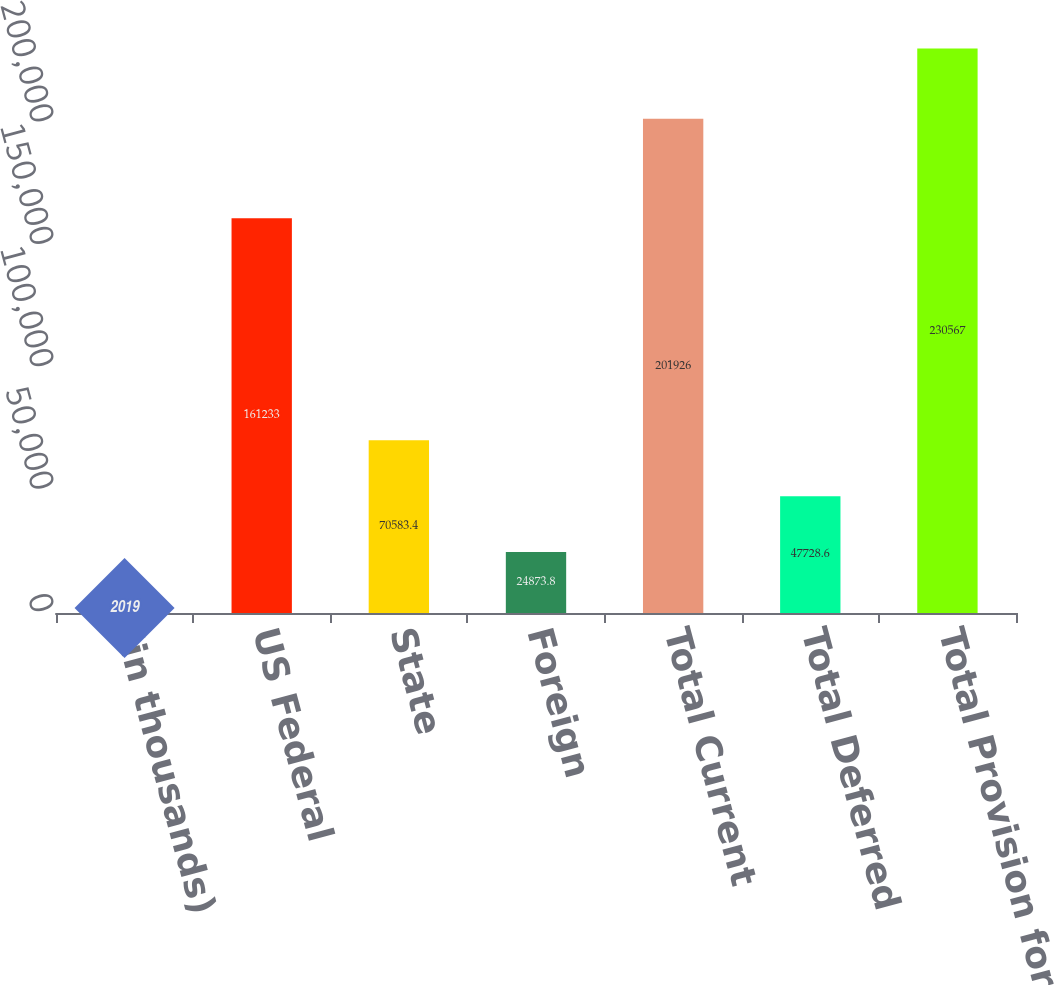Convert chart. <chart><loc_0><loc_0><loc_500><loc_500><bar_chart><fcel>(in thousands)<fcel>US Federal<fcel>State<fcel>Foreign<fcel>Total Current<fcel>Total Deferred<fcel>Total Provision for Income<nl><fcel>2019<fcel>161233<fcel>70583.4<fcel>24873.8<fcel>201926<fcel>47728.6<fcel>230567<nl></chart> 